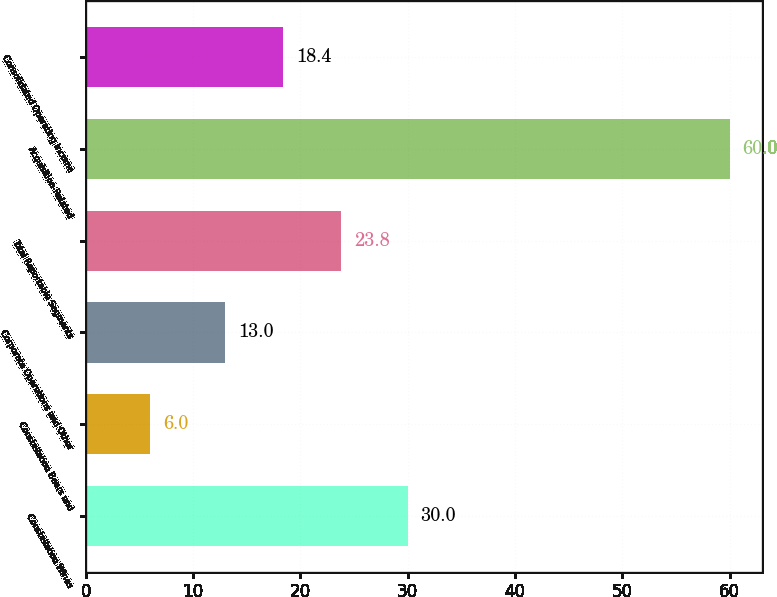Convert chart to OTSL. <chart><loc_0><loc_0><loc_500><loc_500><bar_chart><fcel>Constellation Wines<fcel>Constellation Beers and<fcel>Corporate Operations and Other<fcel>Total Reportable Segments<fcel>Acquisition-Related<fcel>Consolidated Operating Income<nl><fcel>30<fcel>6<fcel>13<fcel>23.8<fcel>60<fcel>18.4<nl></chart> 